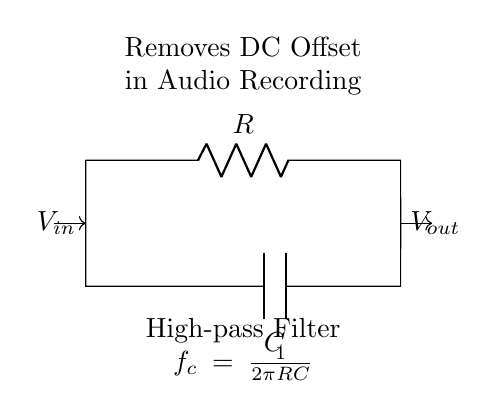What type of filter is shown in the diagram? The circuit is identified as a high-pass filter due to its function of allowing high-frequency signals to pass while attenuating DC and low-frequency signals. The presence of a capacitor in series and a resistor confirms this configuration.
Answer: High-pass filter What are the components used in this circuit? The circuit contains two components: a resistor denoted by R and a capacitor denoted by C. These components are critical in determining the filter's characteristics, such as cutoff frequency.
Answer: Resistor and Capacitor What is the function of this circuit in audio recording? The primary function of this circuit is to remove DC offset from audio signals, which can distort audio quality. This is an essential process in audio setups to ensure clean and accurate sound reproduction.
Answer: Removes DC Offset How is the cutoff frequency calculated in this circuit? The cutoff frequency, denoted as f_c, is calculated using the formula f_c = 1 / (2πRC). This formula shows that the cutoff frequency is inversely proportional to both R and C, determining which frequencies are allowed to pass through the filter.
Answer: 1 / (2πRC) What will happen to low-frequency signals in this filter? Low-frequency signals will be significantly attenuated or blocked by the high-pass filter. This occurs because the impedance of the capacitor decreases as frequency increases, allowing high frequencies to pass while blocking lower ones.
Answer: Attenuated or blocked Which component determines the filtering effect of this circuit? The capacitor primarily determines the filtering effect, as it reacts to changes in voltage over time and allows high-frequency signals to pass while blocking DC and low frequencies. The resistor also plays a role in establishing the filter's characteristics.
Answer: Capacitor 